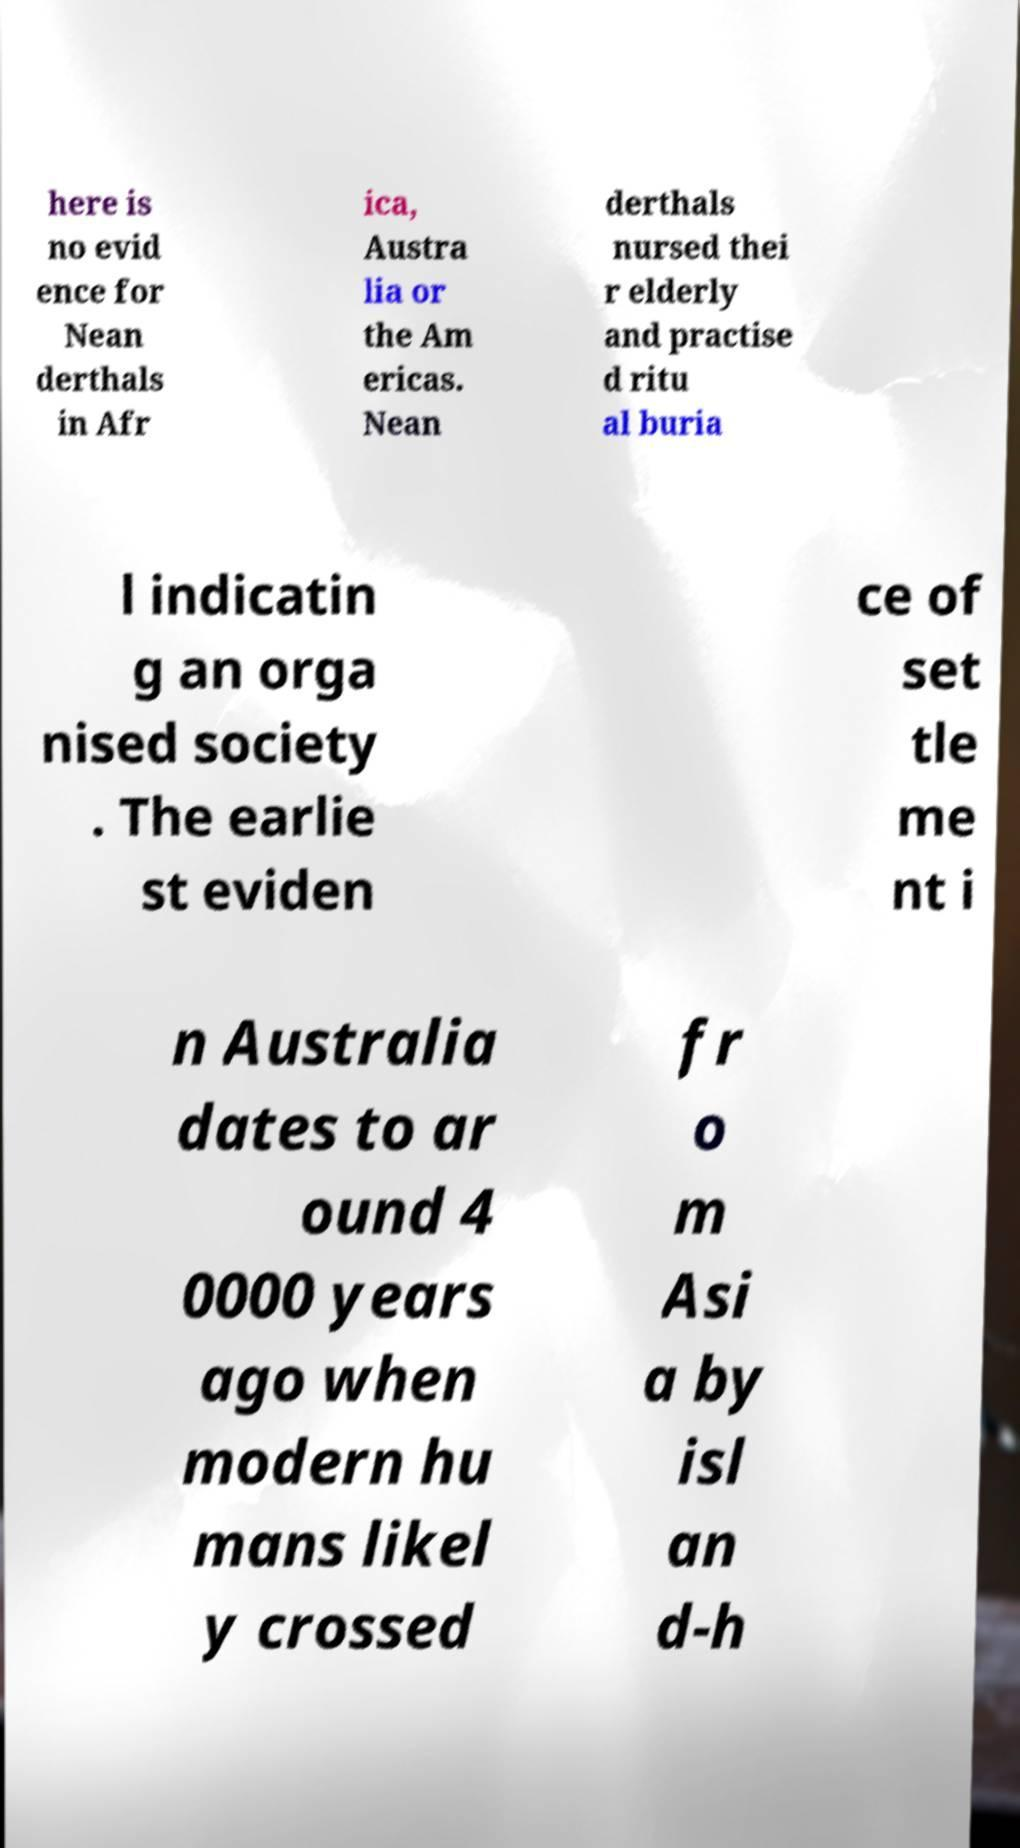Can you read and provide the text displayed in the image?This photo seems to have some interesting text. Can you extract and type it out for me? here is no evid ence for Nean derthals in Afr ica, Austra lia or the Am ericas. Nean derthals nursed thei r elderly and practise d ritu al buria l indicatin g an orga nised society . The earlie st eviden ce of set tle me nt i n Australia dates to ar ound 4 0000 years ago when modern hu mans likel y crossed fr o m Asi a by isl an d-h 